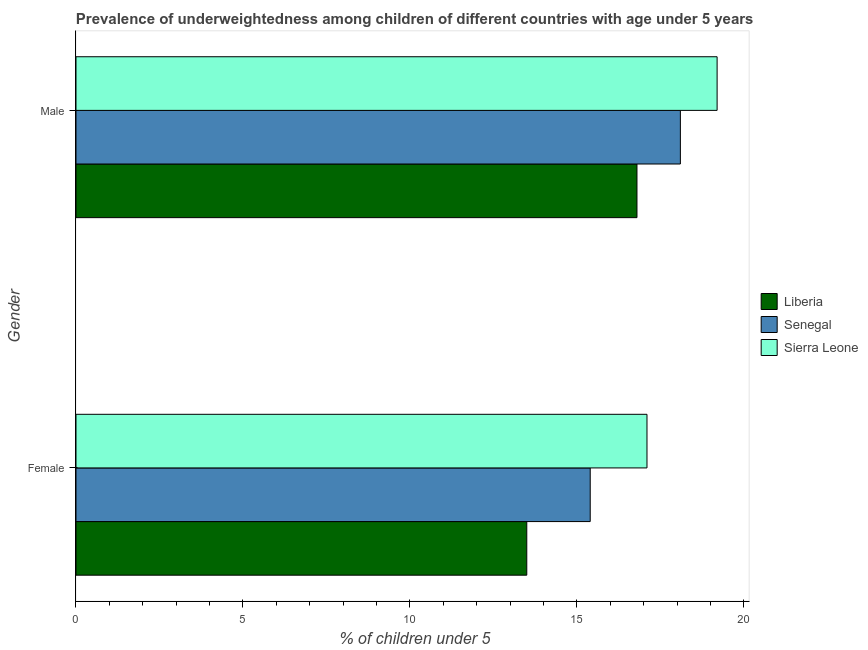How many bars are there on the 1st tick from the top?
Provide a short and direct response. 3. How many bars are there on the 1st tick from the bottom?
Offer a very short reply. 3. What is the percentage of underweighted male children in Senegal?
Your answer should be compact. 18.1. Across all countries, what is the maximum percentage of underweighted male children?
Your response must be concise. 19.2. In which country was the percentage of underweighted female children maximum?
Provide a short and direct response. Sierra Leone. In which country was the percentage of underweighted male children minimum?
Provide a short and direct response. Liberia. What is the total percentage of underweighted male children in the graph?
Your answer should be compact. 54.1. What is the difference between the percentage of underweighted male children in Sierra Leone and that in Senegal?
Offer a terse response. 1.1. What is the difference between the percentage of underweighted male children in Liberia and the percentage of underweighted female children in Sierra Leone?
Your response must be concise. -0.3. What is the average percentage of underweighted female children per country?
Offer a terse response. 15.33. What is the difference between the percentage of underweighted male children and percentage of underweighted female children in Senegal?
Offer a terse response. 2.7. What is the ratio of the percentage of underweighted male children in Senegal to that in Liberia?
Your answer should be very brief. 1.08. Is the percentage of underweighted female children in Liberia less than that in Senegal?
Provide a short and direct response. Yes. What does the 2nd bar from the top in Female represents?
Ensure brevity in your answer.  Senegal. What does the 1st bar from the bottom in Female represents?
Make the answer very short. Liberia. Are all the bars in the graph horizontal?
Keep it short and to the point. Yes. Does the graph contain any zero values?
Provide a succinct answer. No. How many legend labels are there?
Your response must be concise. 3. How are the legend labels stacked?
Provide a short and direct response. Vertical. What is the title of the graph?
Your response must be concise. Prevalence of underweightedness among children of different countries with age under 5 years. What is the label or title of the X-axis?
Make the answer very short.  % of children under 5. What is the  % of children under 5 in Liberia in Female?
Offer a terse response. 13.5. What is the  % of children under 5 in Senegal in Female?
Offer a terse response. 15.4. What is the  % of children under 5 in Sierra Leone in Female?
Your answer should be compact. 17.1. What is the  % of children under 5 of Liberia in Male?
Offer a terse response. 16.8. What is the  % of children under 5 in Senegal in Male?
Give a very brief answer. 18.1. What is the  % of children under 5 in Sierra Leone in Male?
Offer a very short reply. 19.2. Across all Gender, what is the maximum  % of children under 5 in Liberia?
Your response must be concise. 16.8. Across all Gender, what is the maximum  % of children under 5 of Senegal?
Provide a succinct answer. 18.1. Across all Gender, what is the maximum  % of children under 5 in Sierra Leone?
Provide a succinct answer. 19.2. Across all Gender, what is the minimum  % of children under 5 of Liberia?
Your answer should be very brief. 13.5. Across all Gender, what is the minimum  % of children under 5 in Senegal?
Your response must be concise. 15.4. Across all Gender, what is the minimum  % of children under 5 in Sierra Leone?
Keep it short and to the point. 17.1. What is the total  % of children under 5 in Liberia in the graph?
Ensure brevity in your answer.  30.3. What is the total  % of children under 5 in Senegal in the graph?
Keep it short and to the point. 33.5. What is the total  % of children under 5 in Sierra Leone in the graph?
Ensure brevity in your answer.  36.3. What is the difference between the  % of children under 5 of Senegal in Female and that in Male?
Offer a very short reply. -2.7. What is the difference between the  % of children under 5 in Sierra Leone in Female and that in Male?
Make the answer very short. -2.1. What is the difference between the  % of children under 5 in Liberia in Female and the  % of children under 5 in Senegal in Male?
Provide a succinct answer. -4.6. What is the average  % of children under 5 of Liberia per Gender?
Make the answer very short. 15.15. What is the average  % of children under 5 of Senegal per Gender?
Ensure brevity in your answer.  16.75. What is the average  % of children under 5 of Sierra Leone per Gender?
Ensure brevity in your answer.  18.15. What is the difference between the  % of children under 5 in Liberia and  % of children under 5 in Sierra Leone in Female?
Make the answer very short. -3.6. What is the difference between the  % of children under 5 of Senegal and  % of children under 5 of Sierra Leone in Female?
Provide a short and direct response. -1.7. What is the difference between the  % of children under 5 of Liberia and  % of children under 5 of Senegal in Male?
Make the answer very short. -1.3. What is the ratio of the  % of children under 5 in Liberia in Female to that in Male?
Make the answer very short. 0.8. What is the ratio of the  % of children under 5 of Senegal in Female to that in Male?
Your answer should be compact. 0.85. What is the ratio of the  % of children under 5 of Sierra Leone in Female to that in Male?
Give a very brief answer. 0.89. What is the difference between the highest and the second highest  % of children under 5 of Liberia?
Your answer should be very brief. 3.3. What is the difference between the highest and the second highest  % of children under 5 of Senegal?
Keep it short and to the point. 2.7. What is the difference between the highest and the lowest  % of children under 5 of Liberia?
Provide a short and direct response. 3.3. What is the difference between the highest and the lowest  % of children under 5 of Senegal?
Provide a short and direct response. 2.7. 